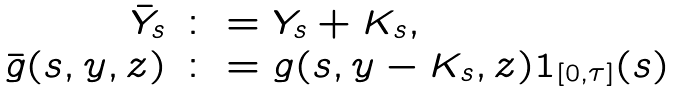<formula> <loc_0><loc_0><loc_500><loc_500>\begin{array} { r l } \bar { Y } _ { s } & \colon = Y _ { s } + K _ { s } , \\ \bar { g } ( s , y , z ) & \colon = g ( s , y - K _ { s } , z ) 1 _ { [ 0 , \tau ] } ( s ) \end{array}</formula> 